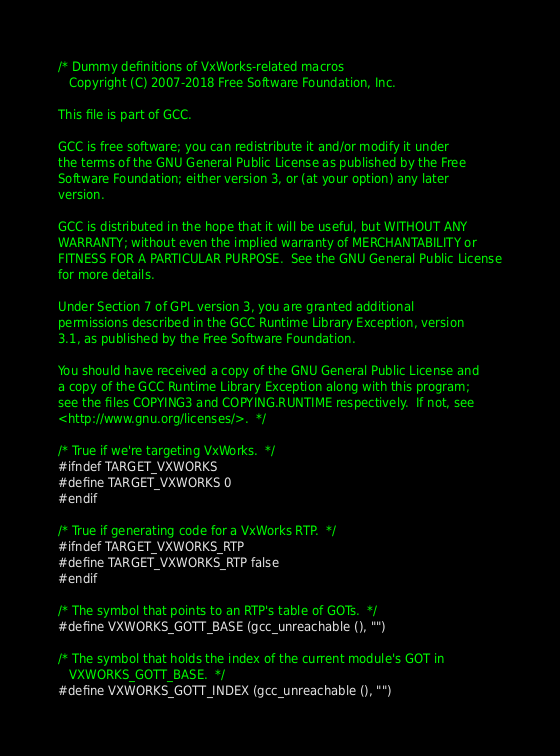Convert code to text. <code><loc_0><loc_0><loc_500><loc_500><_C_>/* Dummy definitions of VxWorks-related macros
   Copyright (C) 2007-2018 Free Software Foundation, Inc.

This file is part of GCC.

GCC is free software; you can redistribute it and/or modify it under
the terms of the GNU General Public License as published by the Free
Software Foundation; either version 3, or (at your option) any later
version.

GCC is distributed in the hope that it will be useful, but WITHOUT ANY
WARRANTY; without even the implied warranty of MERCHANTABILITY or
FITNESS FOR A PARTICULAR PURPOSE.  See the GNU General Public License
for more details.

Under Section 7 of GPL version 3, you are granted additional
permissions described in the GCC Runtime Library Exception, version
3.1, as published by the Free Software Foundation.

You should have received a copy of the GNU General Public License and
a copy of the GCC Runtime Library Exception along with this program;
see the files COPYING3 and COPYING.RUNTIME respectively.  If not, see
<http://www.gnu.org/licenses/>.  */

/* True if we're targeting VxWorks.  */
#ifndef TARGET_VXWORKS
#define TARGET_VXWORKS 0
#endif

/* True if generating code for a VxWorks RTP.  */
#ifndef TARGET_VXWORKS_RTP
#define TARGET_VXWORKS_RTP false
#endif

/* The symbol that points to an RTP's table of GOTs.  */
#define VXWORKS_GOTT_BASE (gcc_unreachable (), "")

/* The symbol that holds the index of the current module's GOT in
   VXWORKS_GOTT_BASE.  */
#define VXWORKS_GOTT_INDEX (gcc_unreachable (), "")
</code> 